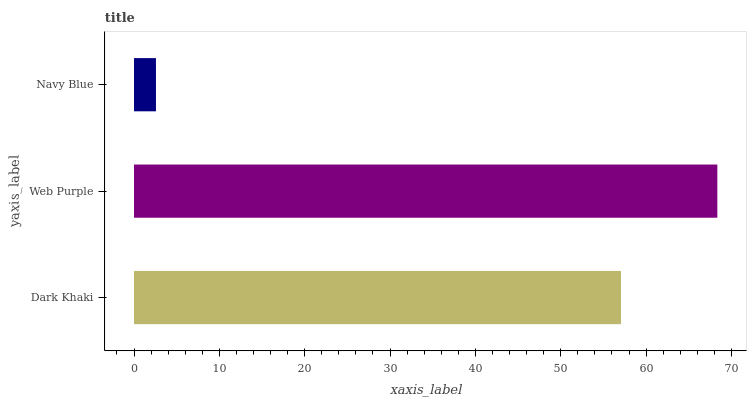Is Navy Blue the minimum?
Answer yes or no. Yes. Is Web Purple the maximum?
Answer yes or no. Yes. Is Web Purple the minimum?
Answer yes or no. No. Is Navy Blue the maximum?
Answer yes or no. No. Is Web Purple greater than Navy Blue?
Answer yes or no. Yes. Is Navy Blue less than Web Purple?
Answer yes or no. Yes. Is Navy Blue greater than Web Purple?
Answer yes or no. No. Is Web Purple less than Navy Blue?
Answer yes or no. No. Is Dark Khaki the high median?
Answer yes or no. Yes. Is Dark Khaki the low median?
Answer yes or no. Yes. Is Web Purple the high median?
Answer yes or no. No. Is Navy Blue the low median?
Answer yes or no. No. 